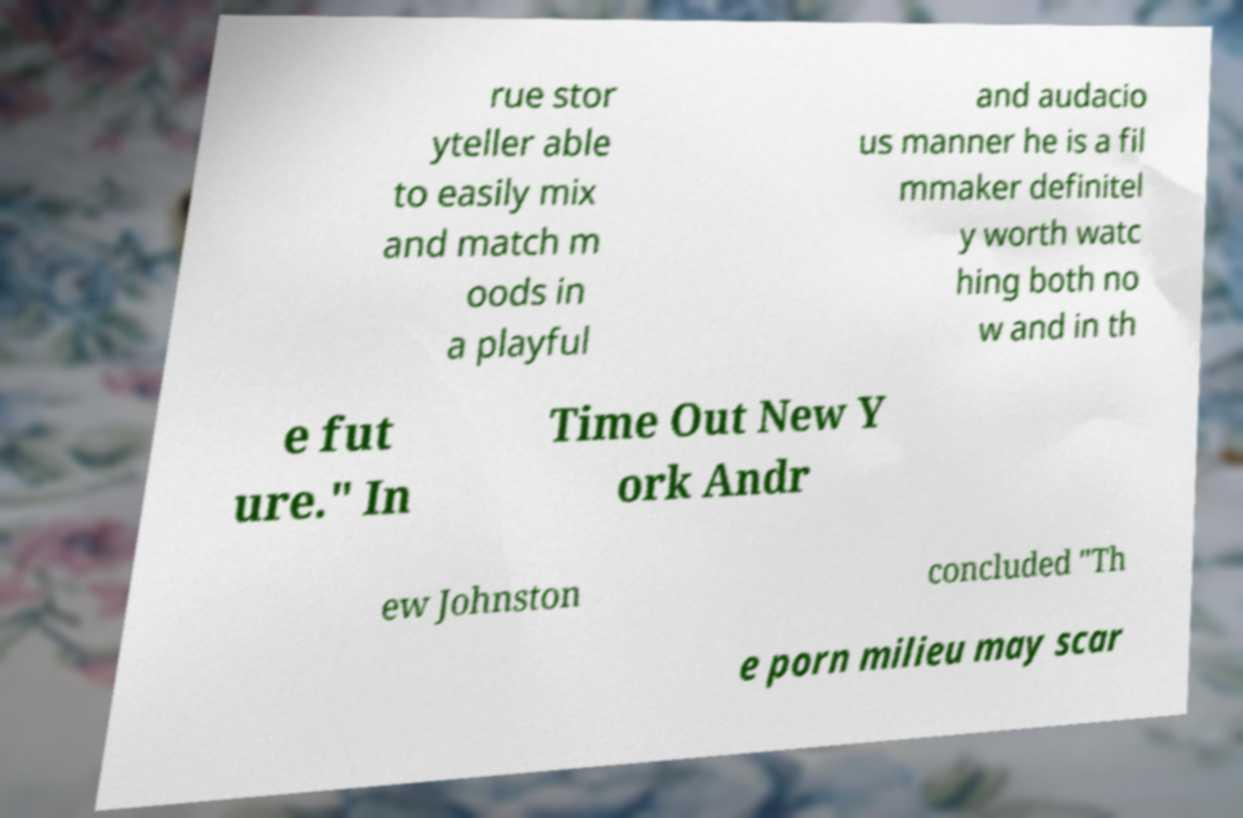Could you extract and type out the text from this image? rue stor yteller able to easily mix and match m oods in a playful and audacio us manner he is a fil mmaker definitel y worth watc hing both no w and in th e fut ure." In Time Out New Y ork Andr ew Johnston concluded "Th e porn milieu may scar 